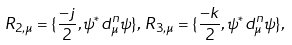<formula> <loc_0><loc_0><loc_500><loc_500>R _ { 2 , \mu } = \{ \frac { - j } { 2 } , \psi ^ { * } d ^ { n } _ { \mu } \psi \} , \, R _ { 3 , \mu } = \{ \frac { - k } { 2 } , \psi ^ { * } d ^ { n } _ { \mu } \psi \} ,</formula> 